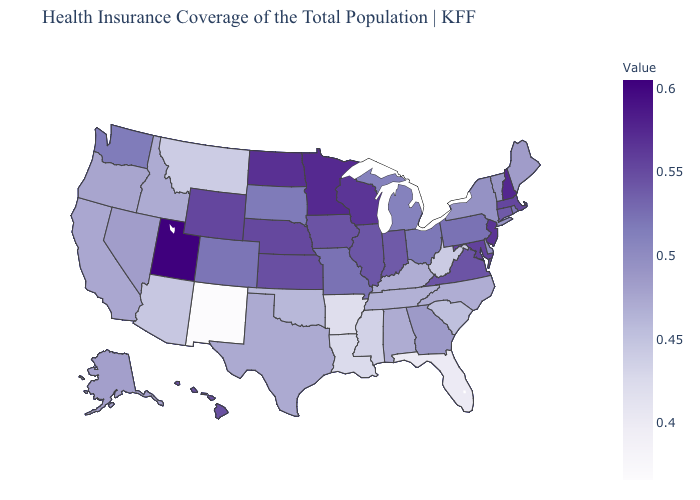Among the states that border Wisconsin , which have the lowest value?
Concise answer only. Michigan. Does the map have missing data?
Be succinct. No. Does Iowa have a higher value than New York?
Quick response, please. Yes. 